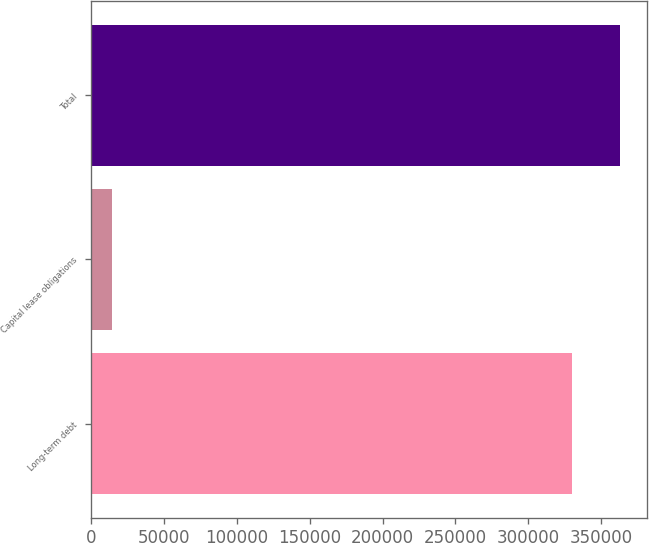Convert chart to OTSL. <chart><loc_0><loc_0><loc_500><loc_500><bar_chart><fcel>Long-term debt<fcel>Capital lease obligations<fcel>Total<nl><fcel>330000<fcel>14516<fcel>363000<nl></chart> 